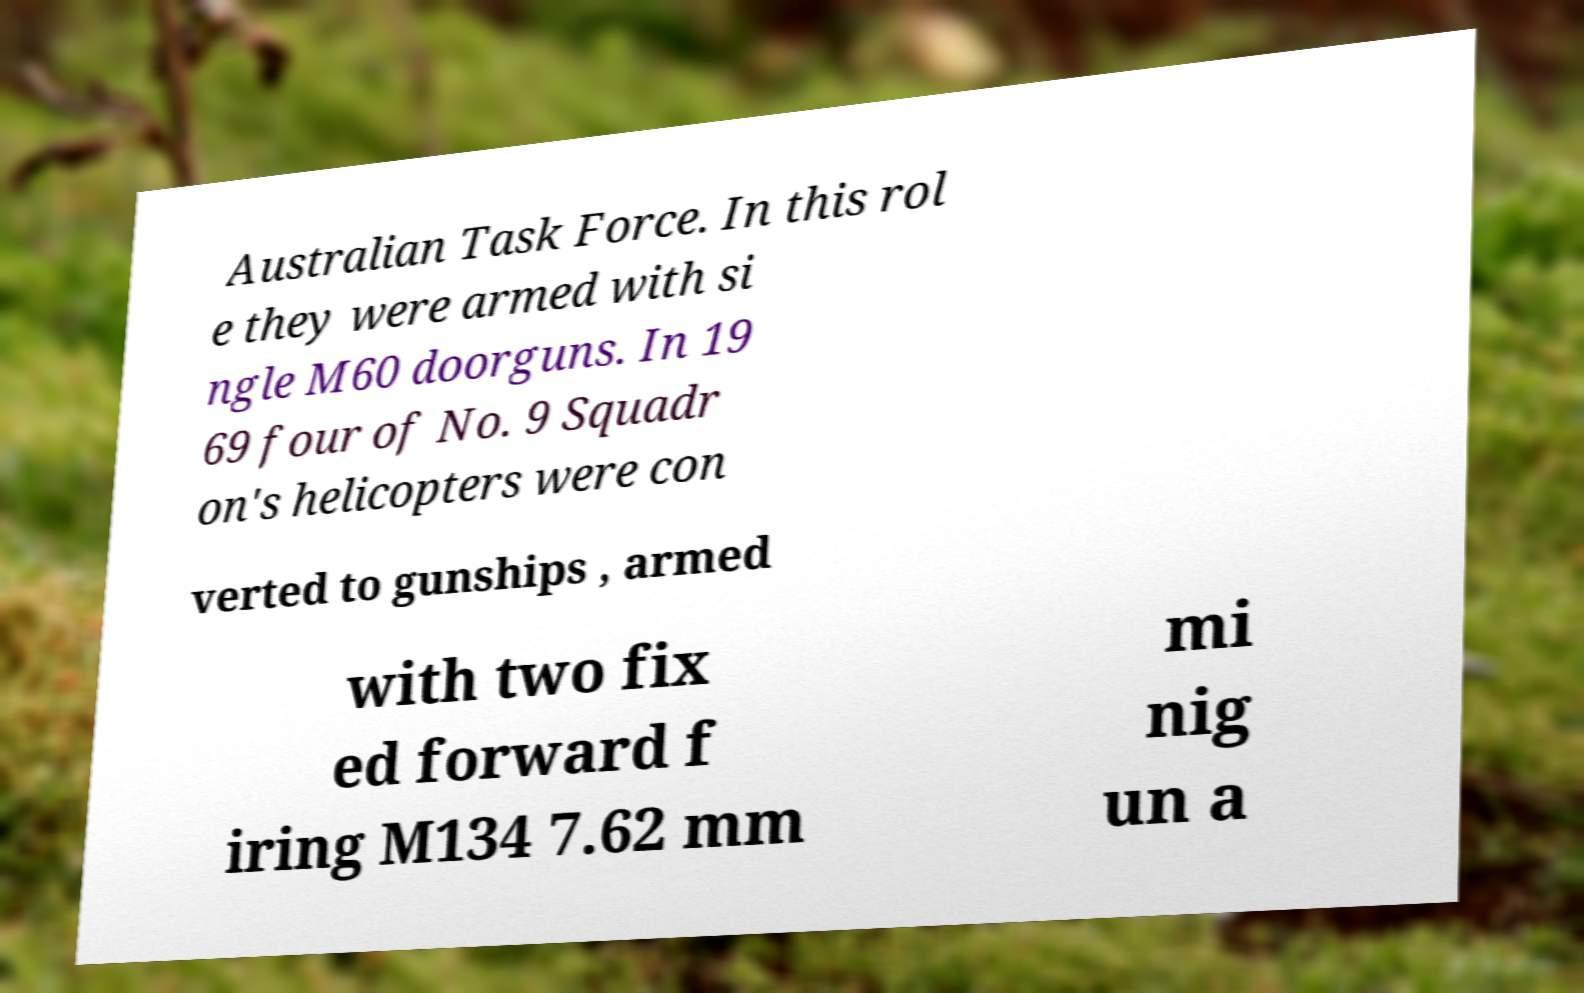For documentation purposes, I need the text within this image transcribed. Could you provide that? Australian Task Force. In this rol e they were armed with si ngle M60 doorguns. In 19 69 four of No. 9 Squadr on's helicopters were con verted to gunships , armed with two fix ed forward f iring M134 7.62 mm mi nig un a 